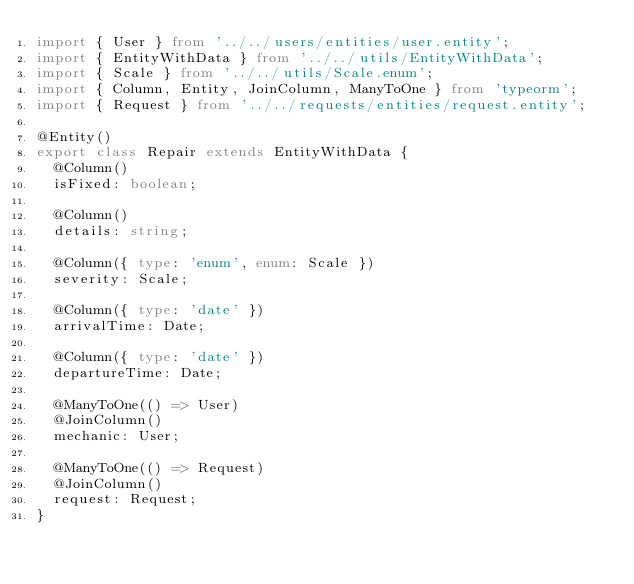Convert code to text. <code><loc_0><loc_0><loc_500><loc_500><_TypeScript_>import { User } from '../../users/entities/user.entity';
import { EntityWithData } from '../../utils/EntityWithData';
import { Scale } from '../../utils/Scale.enum';
import { Column, Entity, JoinColumn, ManyToOne } from 'typeorm';
import { Request } from '../../requests/entities/request.entity';

@Entity()
export class Repair extends EntityWithData {
  @Column()
  isFixed: boolean;

  @Column()
  details: string;

  @Column({ type: 'enum', enum: Scale })
  severity: Scale;

  @Column({ type: 'date' })
  arrivalTime: Date;

  @Column({ type: 'date' })
  departureTime: Date;

  @ManyToOne(() => User)
  @JoinColumn()
  mechanic: User;

  @ManyToOne(() => Request)
  @JoinColumn()
  request: Request;
}
</code> 